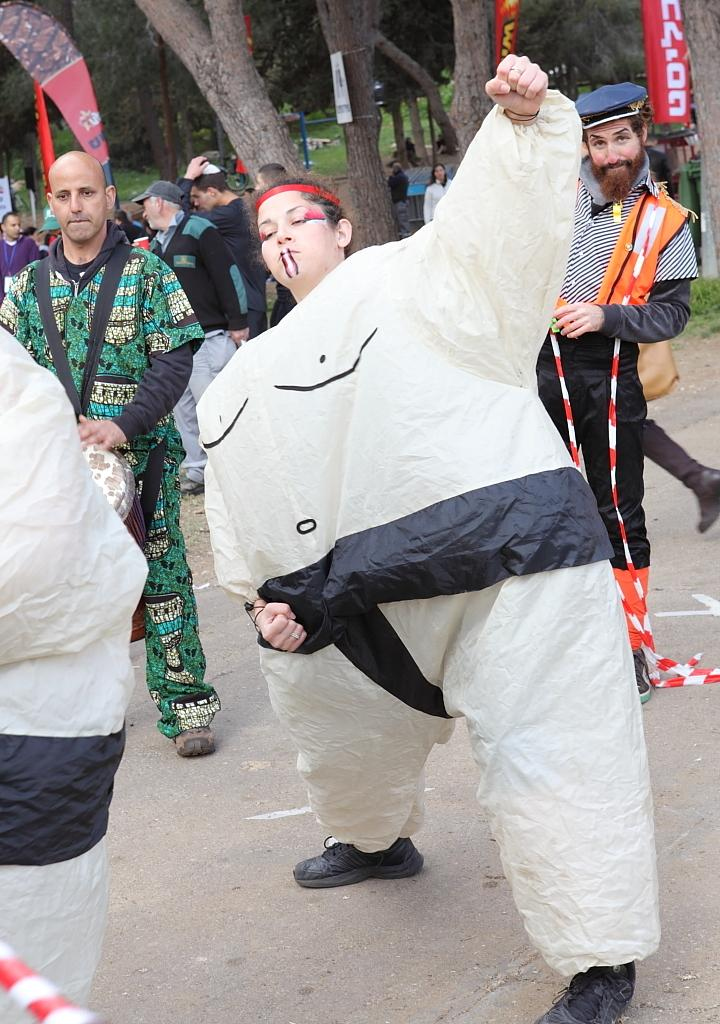How many persons are in fancy dresses in the image? There are two persons in fancy dresses in the image. What are the two persons doing in the image? The two persons are standing. What can be seen in the background of the image? There is a group of people, banners, and trees in the background of the image. How does the beginner learn to dance in the image? There is no indication in the image that a beginner is learning to dance, as the two persons in fancy dresses are already standing. Can you tell me how the dad is interacting with the group of people in the image? There is no dad present in the image; it only features two persons in fancy dresses and a group of people in the background. 